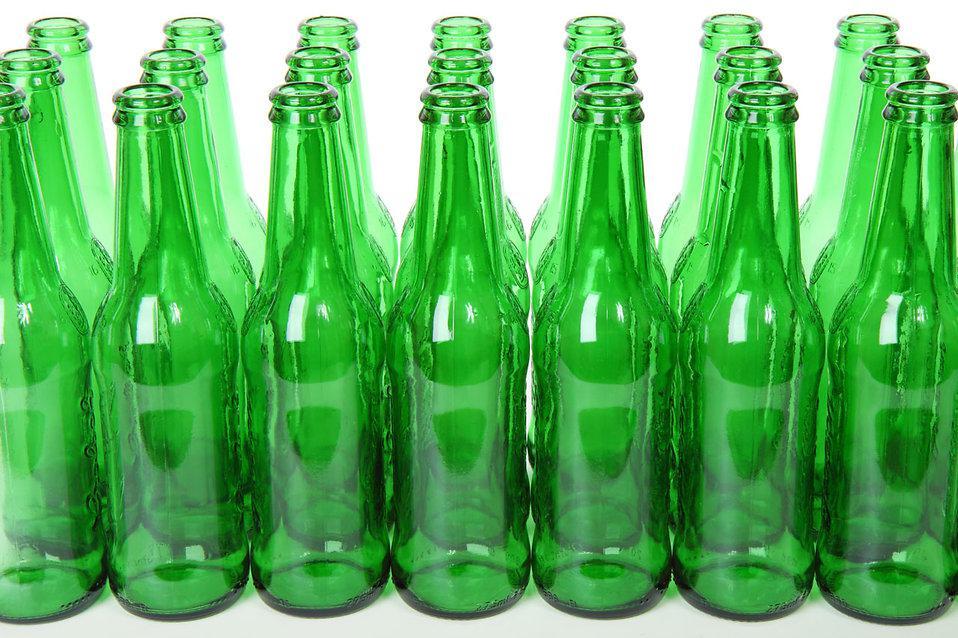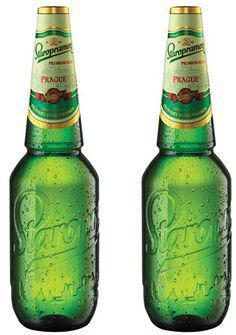The first image is the image on the left, the second image is the image on the right. Analyze the images presented: Is the assertion "A single green beer bottle is shown in one image." valid? Answer yes or no. No. The first image is the image on the left, the second image is the image on the right. Assess this claim about the two images: "An image contains exactly two bottles displayed vertically.". Correct or not? Answer yes or no. Yes. 